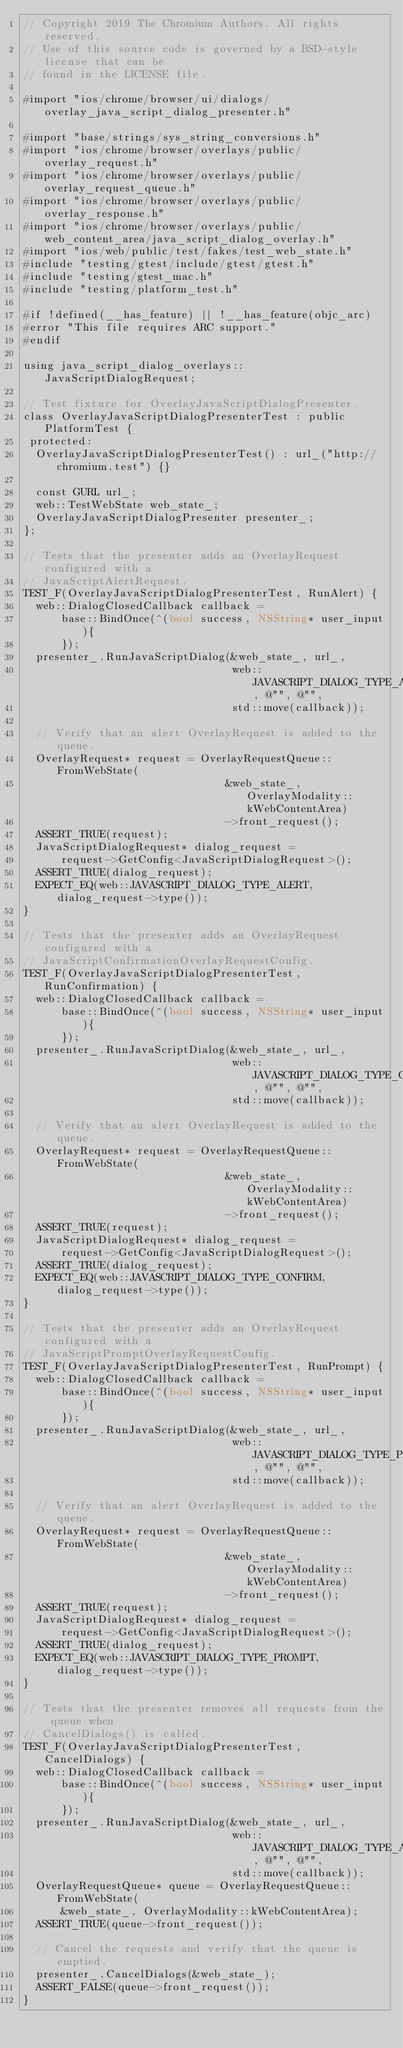Convert code to text. <code><loc_0><loc_0><loc_500><loc_500><_ObjectiveC_>// Copyright 2019 The Chromium Authors. All rights reserved.
// Use of this source code is governed by a BSD-style license that can be
// found in the LICENSE file.

#import "ios/chrome/browser/ui/dialogs/overlay_java_script_dialog_presenter.h"

#import "base/strings/sys_string_conversions.h"
#import "ios/chrome/browser/overlays/public/overlay_request.h"
#import "ios/chrome/browser/overlays/public/overlay_request_queue.h"
#import "ios/chrome/browser/overlays/public/overlay_response.h"
#import "ios/chrome/browser/overlays/public/web_content_area/java_script_dialog_overlay.h"
#import "ios/web/public/test/fakes/test_web_state.h"
#include "testing/gtest/include/gtest/gtest.h"
#include "testing/gtest_mac.h"
#include "testing/platform_test.h"

#if !defined(__has_feature) || !__has_feature(objc_arc)
#error "This file requires ARC support."
#endif

using java_script_dialog_overlays::JavaScriptDialogRequest;

// Test fixture for OverlayJavaScriptDialogPresenter.
class OverlayJavaScriptDialogPresenterTest : public PlatformTest {
 protected:
  OverlayJavaScriptDialogPresenterTest() : url_("http://chromium.test") {}

  const GURL url_;
  web::TestWebState web_state_;
  OverlayJavaScriptDialogPresenter presenter_;
};

// Tests that the presenter adds an OverlayRequest configured with a
// JavaScriptAlertRequest.
TEST_F(OverlayJavaScriptDialogPresenterTest, RunAlert) {
  web::DialogClosedCallback callback =
      base::BindOnce(^(bool success, NSString* user_input){
      });
  presenter_.RunJavaScriptDialog(&web_state_, url_,
                                 web::JAVASCRIPT_DIALOG_TYPE_ALERT, @"", @"",
                                 std::move(callback));

  // Verify that an alert OverlayRequest is added to the queue.
  OverlayRequest* request = OverlayRequestQueue::FromWebState(
                                &web_state_, OverlayModality::kWebContentArea)
                                ->front_request();
  ASSERT_TRUE(request);
  JavaScriptDialogRequest* dialog_request =
      request->GetConfig<JavaScriptDialogRequest>();
  ASSERT_TRUE(dialog_request);
  EXPECT_EQ(web::JAVASCRIPT_DIALOG_TYPE_ALERT, dialog_request->type());
}

// Tests that the presenter adds an OverlayRequest configured with a
// JavaScriptConfirmationOverlayRequestConfig.
TEST_F(OverlayJavaScriptDialogPresenterTest, RunConfirmation) {
  web::DialogClosedCallback callback =
      base::BindOnce(^(bool success, NSString* user_input){
      });
  presenter_.RunJavaScriptDialog(&web_state_, url_,
                                 web::JAVASCRIPT_DIALOG_TYPE_CONFIRM, @"", @"",
                                 std::move(callback));

  // Verify that an alert OverlayRequest is added to the queue.
  OverlayRequest* request = OverlayRequestQueue::FromWebState(
                                &web_state_, OverlayModality::kWebContentArea)
                                ->front_request();
  ASSERT_TRUE(request);
  JavaScriptDialogRequest* dialog_request =
      request->GetConfig<JavaScriptDialogRequest>();
  ASSERT_TRUE(dialog_request);
  EXPECT_EQ(web::JAVASCRIPT_DIALOG_TYPE_CONFIRM, dialog_request->type());
}

// Tests that the presenter adds an OverlayRequest configured with a
// JavaScriptPromptOverlayRequestConfig.
TEST_F(OverlayJavaScriptDialogPresenterTest, RunPrompt) {
  web::DialogClosedCallback callback =
      base::BindOnce(^(bool success, NSString* user_input){
      });
  presenter_.RunJavaScriptDialog(&web_state_, url_,
                                 web::JAVASCRIPT_DIALOG_TYPE_PROMPT, @"", @"",
                                 std::move(callback));

  // Verify that an alert OverlayRequest is added to the queue.
  OverlayRequest* request = OverlayRequestQueue::FromWebState(
                                &web_state_, OverlayModality::kWebContentArea)
                                ->front_request();
  ASSERT_TRUE(request);
  JavaScriptDialogRequest* dialog_request =
      request->GetConfig<JavaScriptDialogRequest>();
  ASSERT_TRUE(dialog_request);
  EXPECT_EQ(web::JAVASCRIPT_DIALOG_TYPE_PROMPT, dialog_request->type());
}

// Tests that the presenter removes all requests from the queue when
// CancelDialogs() is called.
TEST_F(OverlayJavaScriptDialogPresenterTest, CancelDialogs) {
  web::DialogClosedCallback callback =
      base::BindOnce(^(bool success, NSString* user_input){
      });
  presenter_.RunJavaScriptDialog(&web_state_, url_,
                                 web::JAVASCRIPT_DIALOG_TYPE_ALERT, @"", @"",
                                 std::move(callback));
  OverlayRequestQueue* queue = OverlayRequestQueue::FromWebState(
      &web_state_, OverlayModality::kWebContentArea);
  ASSERT_TRUE(queue->front_request());

  // Cancel the requests and verify that the queue is emptied.
  presenter_.CancelDialogs(&web_state_);
  ASSERT_FALSE(queue->front_request());
}
</code> 